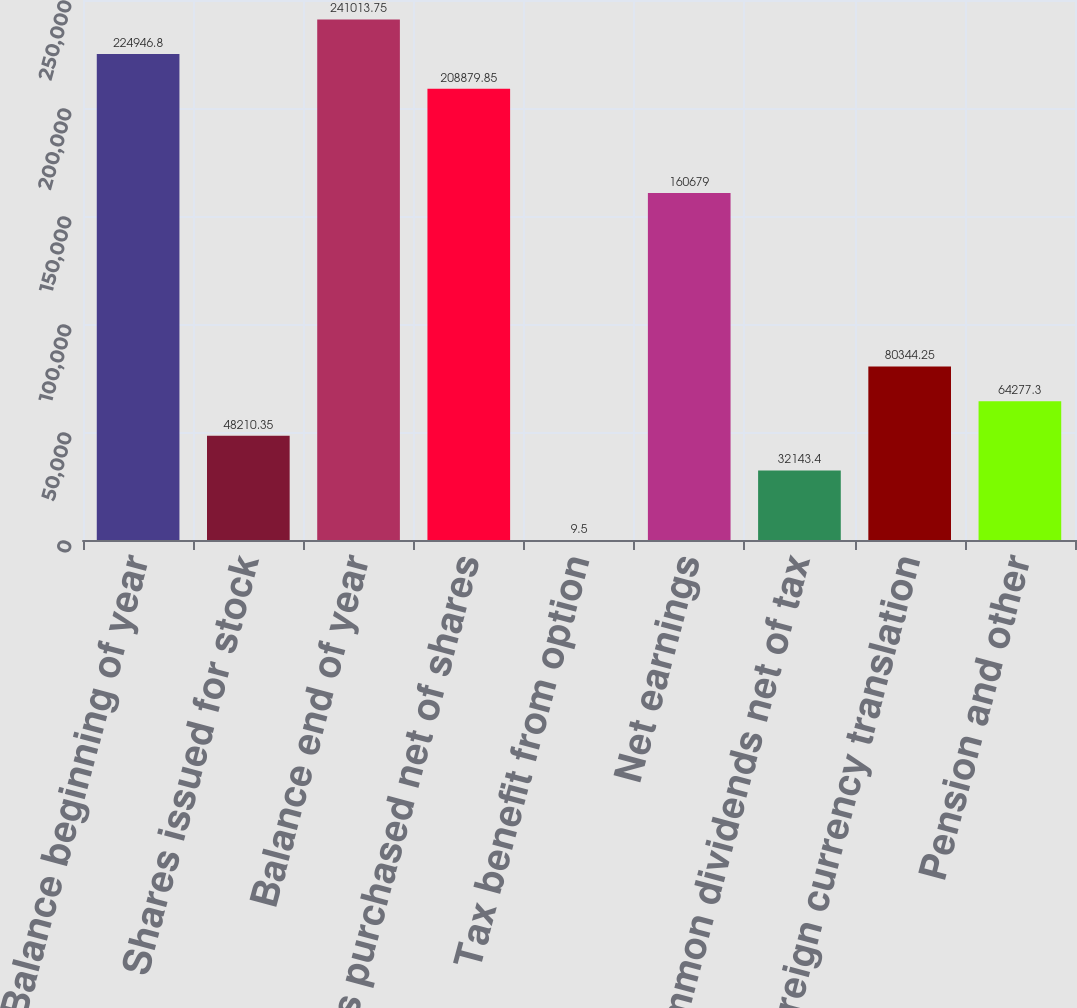<chart> <loc_0><loc_0><loc_500><loc_500><bar_chart><fcel>Balance beginning of year<fcel>Shares issued for stock<fcel>Balance end of year<fcel>Shares purchased net of shares<fcel>Tax benefit from option<fcel>Net earnings<fcel>Common dividends net of tax<fcel>Foreign currency translation<fcel>Pension and other<nl><fcel>224947<fcel>48210.3<fcel>241014<fcel>208880<fcel>9.5<fcel>160679<fcel>32143.4<fcel>80344.2<fcel>64277.3<nl></chart> 